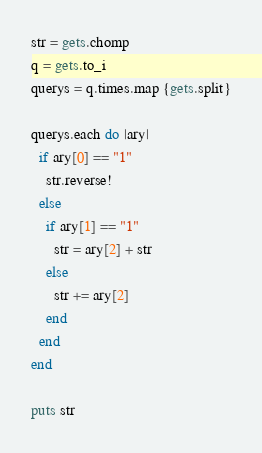<code> <loc_0><loc_0><loc_500><loc_500><_Ruby_>str = gets.chomp
q = gets.to_i
querys = q.times.map {gets.split}

querys.each do |ary|
  if ary[0] == "1"
    str.reverse!
  else
    if ary[1] == "1"
      str = ary[2] + str
    else
      str += ary[2]
    end
  end
end

puts str</code> 